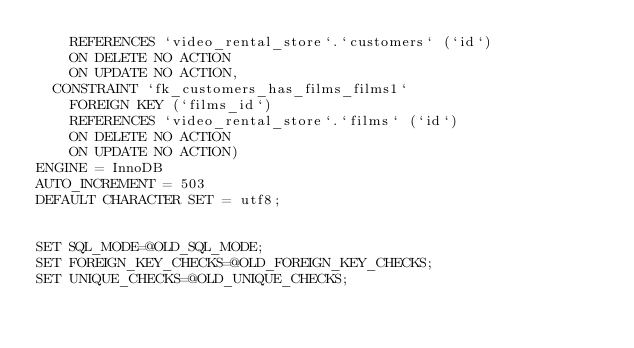Convert code to text. <code><loc_0><loc_0><loc_500><loc_500><_SQL_>    REFERENCES `video_rental_store`.`customers` (`id`)
    ON DELETE NO ACTION
    ON UPDATE NO ACTION,
  CONSTRAINT `fk_customers_has_films_films1`
    FOREIGN KEY (`films_id`)
    REFERENCES `video_rental_store`.`films` (`id`)
    ON DELETE NO ACTION
    ON UPDATE NO ACTION)
ENGINE = InnoDB
AUTO_INCREMENT = 503
DEFAULT CHARACTER SET = utf8;


SET SQL_MODE=@OLD_SQL_MODE;
SET FOREIGN_KEY_CHECKS=@OLD_FOREIGN_KEY_CHECKS;
SET UNIQUE_CHECKS=@OLD_UNIQUE_CHECKS;
</code> 